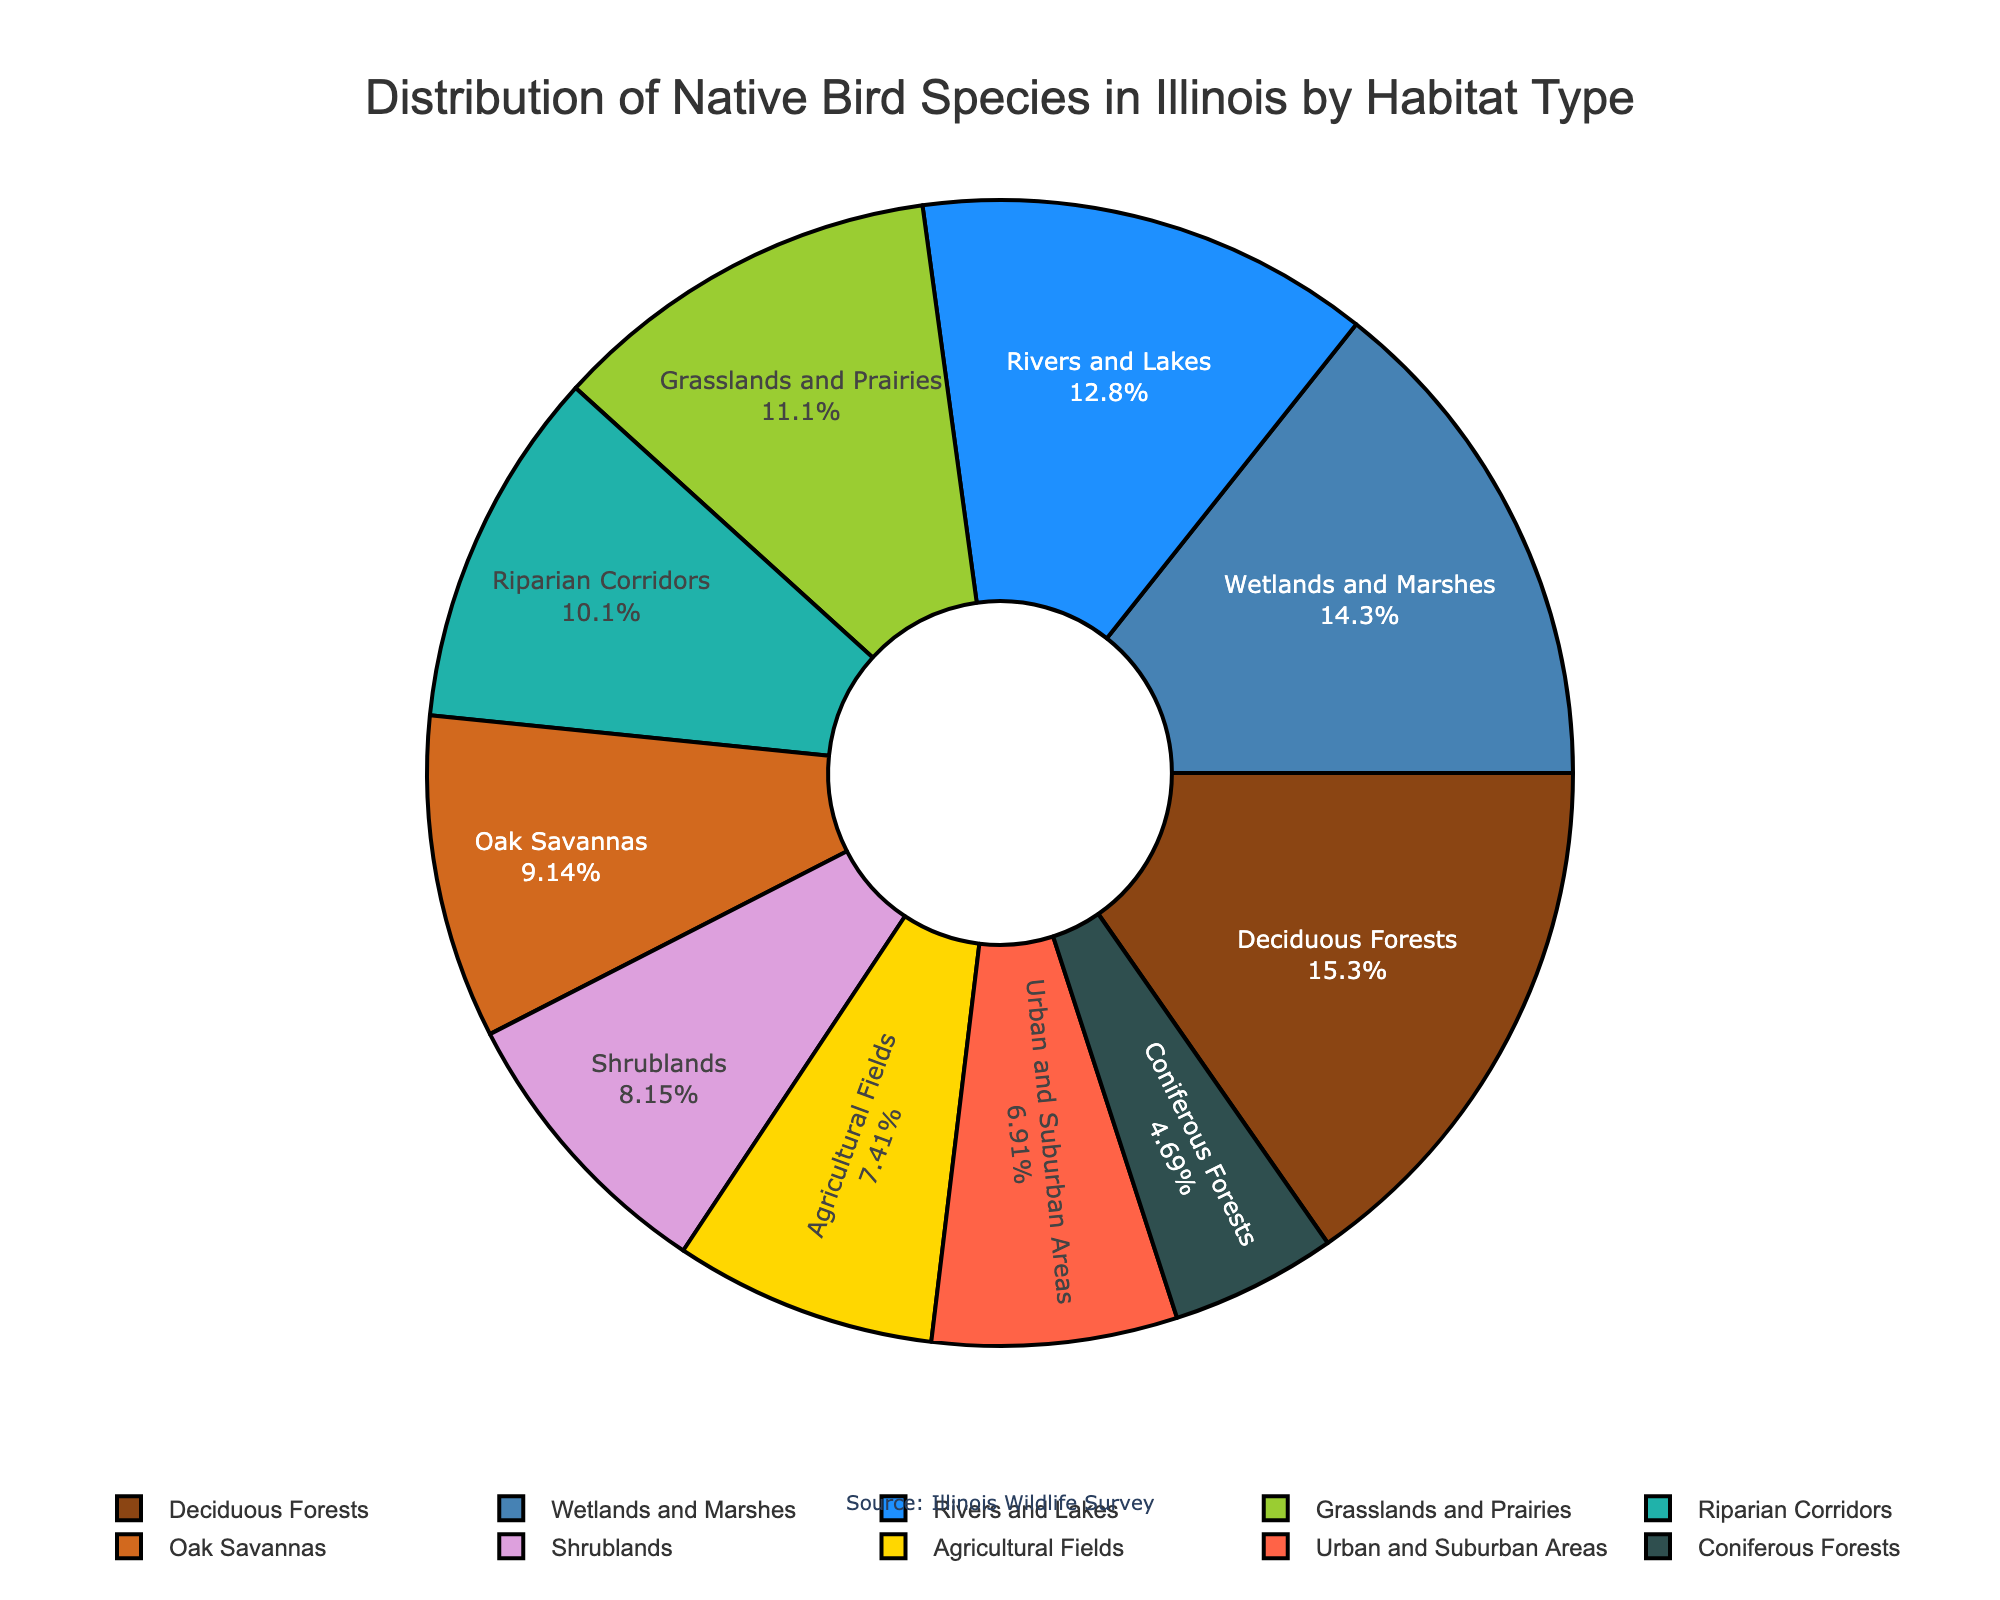How many more native bird species are there in deciduous forests than in coniferous forests? To find the number of additional native bird species in deciduous forests compared to coniferous forests, subtract the total for coniferous forests (19) from the total for deciduous forests (62). 62 - 19 = 43.
Answer: 43 Which habitat has the fewest native bird species? By examining the pie chart, identify the smallest segment. Coniferous forests have the fewest native bird species with a count of 19.
Answer: Coniferous Forests What is the combined percentage of native bird species in wetlands and marshes and rivers and lakes? First, sum the number of bird species in wetlands and marshes (58) and rivers and lakes (52). The total is 58 + 52 = 110. Next, divide this by the total number of bird species across all habitats (405) and multiply by 100 to find the percentage: (110 / 405) * 100 = 27.16%.
Answer: 27.16% Are there more native bird species in grasslands and prairies or urban and suburban areas? Check the figure and compare the segments for grasslands and prairies (45) and urban and suburban areas (28). Grasslands and prairies have more native bird species.
Answer: Grasslands and Prairies What habitat type hosts approximately one-third of the total native bird species? Start by calculating one-third of the total number of native bird species (405): 405 / 3 ≈ 135. The segment closest to 135 native bird species relative to the total is deciduous forests with 62 species. While it's not exactly one-third, it's the visually dominant category, but none are exactly one-third.
Answer: None exactly List the habitats in descending order of their native bird species count. Order the habitats by their values from the highest to the lowest: 1) Deciduous Forests (62), 2) Wetlands and Marshes (58), 3) Rivers and Lakes (52), 4) Grasslands and Prairies (45), 5) Riparian Corridors (41), 6) Oak Savannas (37), 7) Shrublands (33), 8) Agricultural Fields (30), 9) Urban and Suburban Areas (28), 10) Coniferous Forests (19).
Answer: Deciduous Forests, Wetlands and Marshes, Rivers and Lakes, Grasslands and Prairies, Riparian Corridors, Oak Savannas, Shrublands, Agricultural Fields, Urban and Suburban Areas, Coniferous Forests Which type of habitat shares equal numbers of native bird species with neither Shrublands nor Urban and Suburban areas? Both Shrublands and Urban and Suburban areas have 33 and 28 bird species respectively. No other habitat has the exact same count of native bird species in the figure.
Answer: None What is the difference between the number of native bird species in Oak Savannas and Shrublands combined, compared to those in Agricultural Fields? First, sum the number of bird species in Oak Savannas (37) and Shrublands (33), which gives 37 + 33 = 70. Next, subtract the number in Agricultural Fields (30) from this sum: 70 - 30 = 40.
Answer: 40 Which habitat types have more than 30 native bird species but fewer than 50? Find segments with native bird species numbers greater than 30 but less than 50: Grasslands and Prairies (45), Riparian Corridors (41), Oak Savannas (37), Shrublands (33).
Answer: Grasslands and Prairies, Riparian Corridors, Oak Savannas, Shrublands 